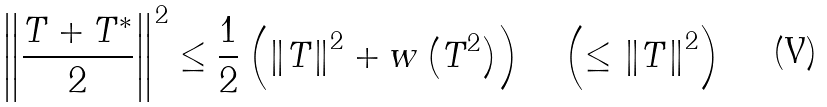Convert formula to latex. <formula><loc_0><loc_0><loc_500><loc_500>\left \| \frac { T + T ^ { \ast } } { 2 } \right \| ^ { 2 } \leq \frac { 1 } { 2 } \left ( \left \| T \right \| ^ { 2 } + w \left ( T ^ { 2 } \right ) \right ) \quad \left ( \leq \left \| T \right \| ^ { 2 } \right )</formula> 